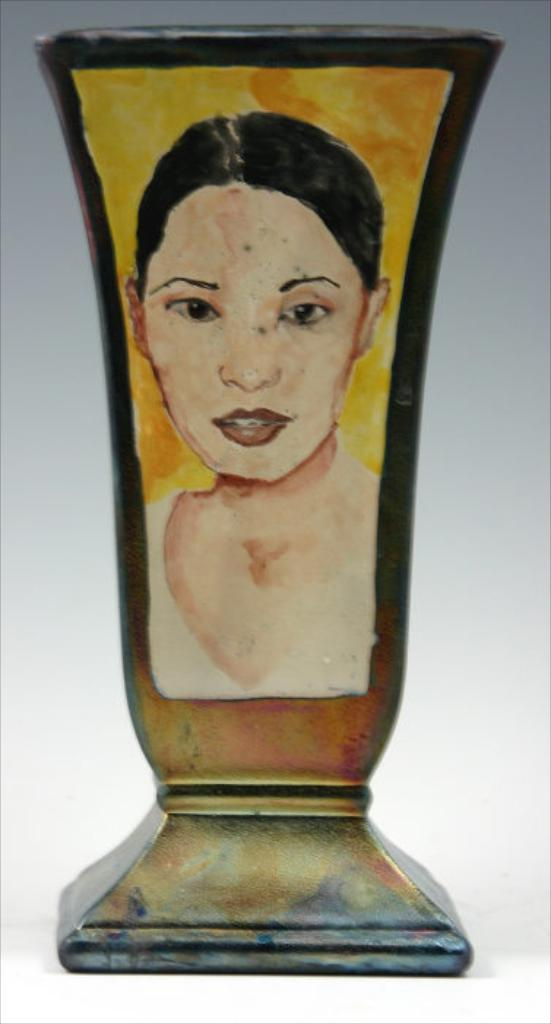What is depicted in the image? There is a painting of a lady in the image. What is the painting placed on? The painting is on an object. Where is the object with the painting located? The object is placed on a surface. What type of berry is being offered to the lady in the painting? There is no berry present in the image, as it only features a painting of a lady. 